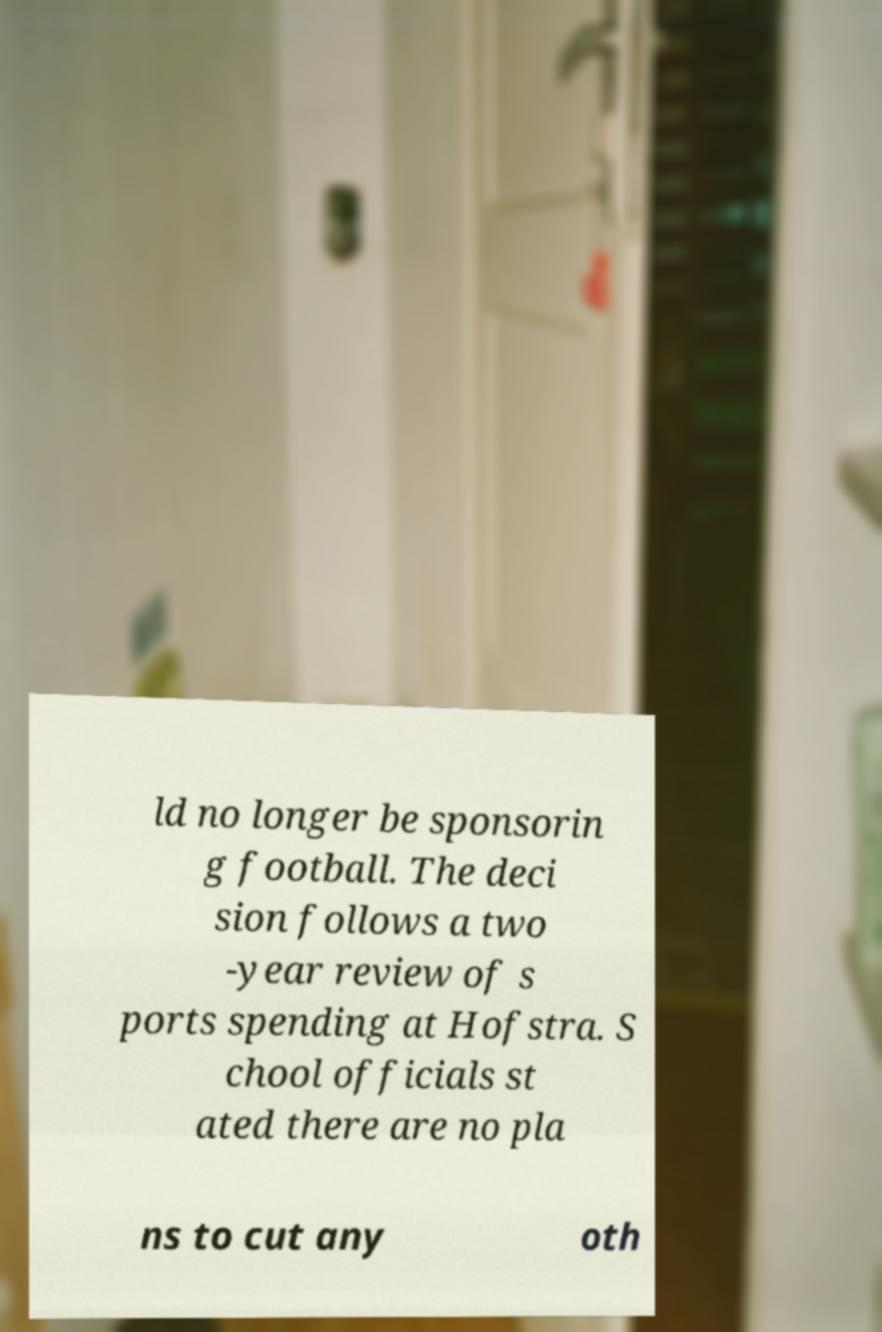Could you assist in decoding the text presented in this image and type it out clearly? ld no longer be sponsorin g football. The deci sion follows a two -year review of s ports spending at Hofstra. S chool officials st ated there are no pla ns to cut any oth 